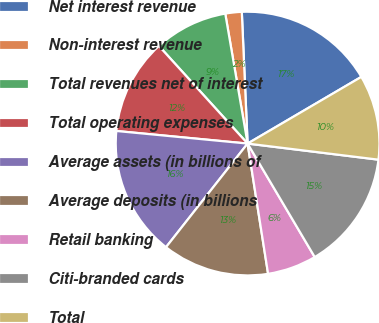<chart> <loc_0><loc_0><loc_500><loc_500><pie_chart><fcel>Net interest revenue<fcel>Non-interest revenue<fcel>Total revenues net of interest<fcel>Total operating expenses<fcel>Average assets (in billions of<fcel>Average deposits (in billions<fcel>Retail banking<fcel>Citi-branded cards<fcel>Total<nl><fcel>17.26%<fcel>2.01%<fcel>9.03%<fcel>11.74%<fcel>15.91%<fcel>13.1%<fcel>6.02%<fcel>14.55%<fcel>10.39%<nl></chart> 